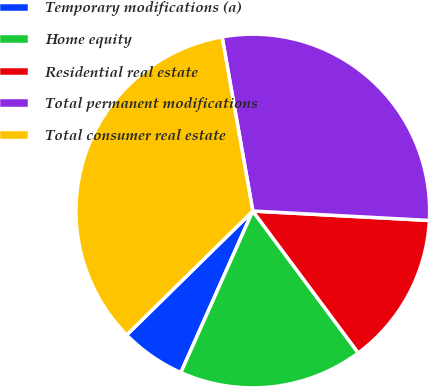Convert chart. <chart><loc_0><loc_0><loc_500><loc_500><pie_chart><fcel>Temporary modifications (a)<fcel>Home equity<fcel>Residential real estate<fcel>Total permanent modifications<fcel>Total consumer real estate<nl><fcel>5.97%<fcel>16.84%<fcel>13.98%<fcel>28.63%<fcel>34.59%<nl></chart> 